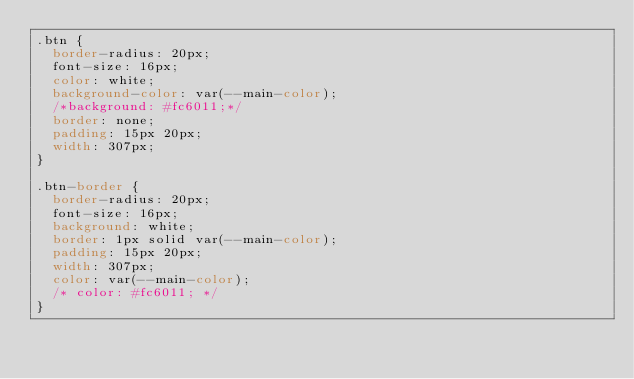<code> <loc_0><loc_0><loc_500><loc_500><_CSS_>.btn {
  border-radius: 20px;
  font-size: 16px;
  color: white;
  background-color: var(--main-color);
  /*background: #fc6011;*/
  border: none;
  padding: 15px 20px;
  width: 307px;
}

.btn-border {
  border-radius: 20px;
  font-size: 16px;
  background: white;
  border: 1px solid var(--main-color);
  padding: 15px 20px;
  width: 307px;
  color: var(--main-color);
  /* color: #fc6011; */
}
</code> 